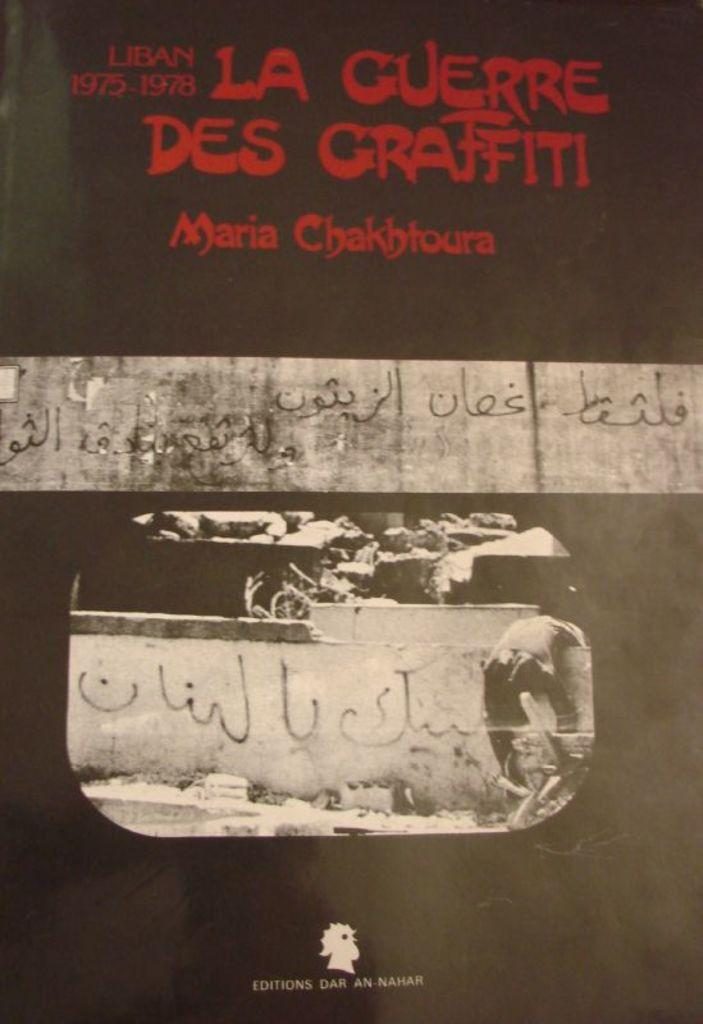Provide a one-sentence caption for the provided image. A bright red graffiti style font proclaims "La Guerre des Graffiti" by Maria Chakhtoura. 